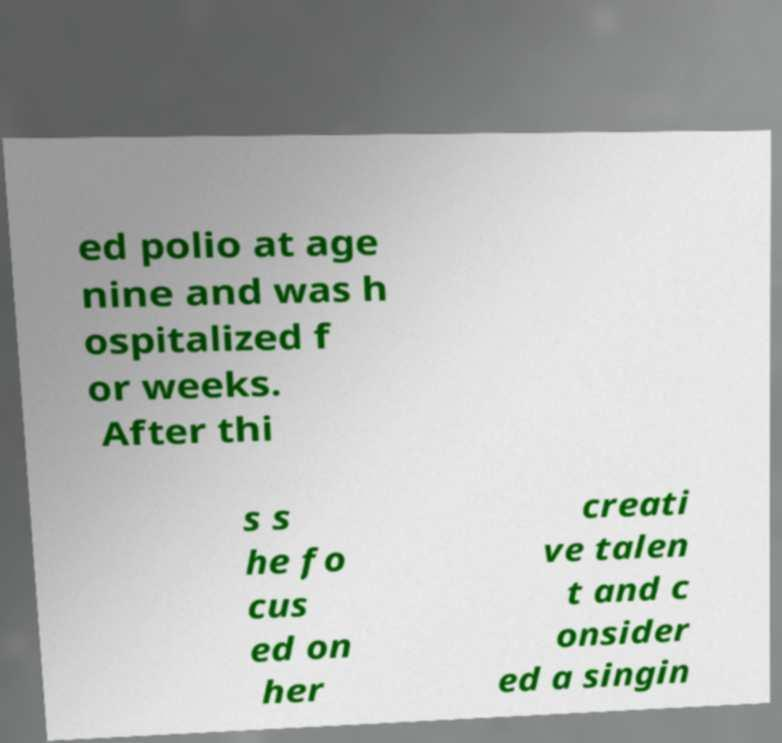Please read and relay the text visible in this image. What does it say? ed polio at age nine and was h ospitalized f or weeks. After thi s s he fo cus ed on her creati ve talen t and c onsider ed a singin 